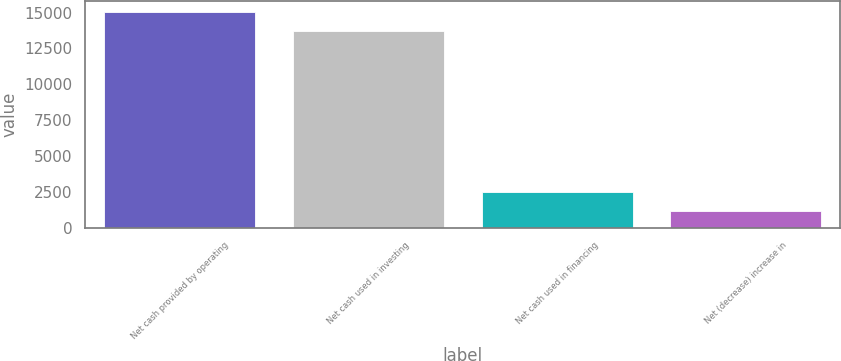Convert chart. <chart><loc_0><loc_0><loc_500><loc_500><bar_chart><fcel>Net cash provided by operating<fcel>Net cash used in investing<fcel>Net cash used in financing<fcel>Net (decrease) increase in<nl><fcel>15056.1<fcel>13711<fcel>2485.1<fcel>1140<nl></chart> 